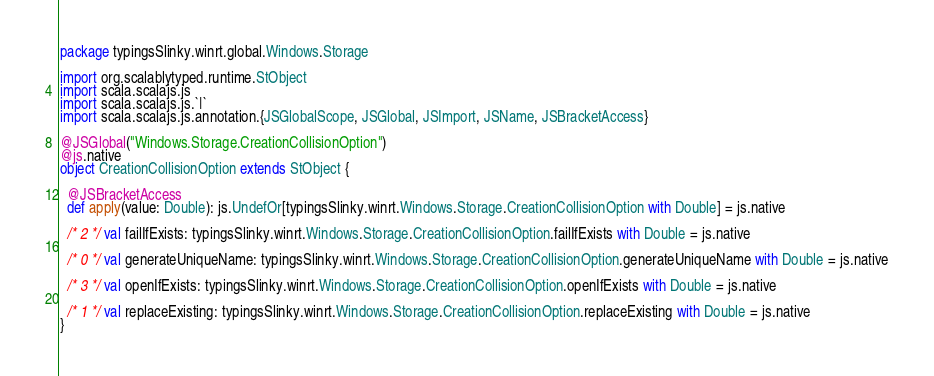Convert code to text. <code><loc_0><loc_0><loc_500><loc_500><_Scala_>package typingsSlinky.winrt.global.Windows.Storage

import org.scalablytyped.runtime.StObject
import scala.scalajs.js
import scala.scalajs.js.`|`
import scala.scalajs.js.annotation.{JSGlobalScope, JSGlobal, JSImport, JSName, JSBracketAccess}

@JSGlobal("Windows.Storage.CreationCollisionOption")
@js.native
object CreationCollisionOption extends StObject {
  
  @JSBracketAccess
  def apply(value: Double): js.UndefOr[typingsSlinky.winrt.Windows.Storage.CreationCollisionOption with Double] = js.native
  
  /* 2 */ val failIfExists: typingsSlinky.winrt.Windows.Storage.CreationCollisionOption.failIfExists with Double = js.native
  
  /* 0 */ val generateUniqueName: typingsSlinky.winrt.Windows.Storage.CreationCollisionOption.generateUniqueName with Double = js.native
  
  /* 3 */ val openIfExists: typingsSlinky.winrt.Windows.Storage.CreationCollisionOption.openIfExists with Double = js.native
  
  /* 1 */ val replaceExisting: typingsSlinky.winrt.Windows.Storage.CreationCollisionOption.replaceExisting with Double = js.native
}
</code> 